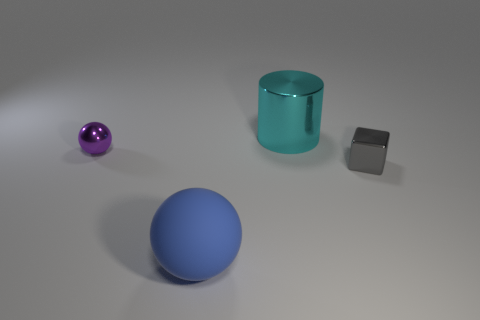Are there any purple metal spheres in front of the small purple sphere?
Give a very brief answer. No. How big is the block?
Ensure brevity in your answer.  Small. There is another object that is the same shape as the tiny purple metal thing; what is its size?
Offer a terse response. Large. How many large shiny objects are to the left of the tiny thing that is to the left of the big blue matte sphere?
Provide a succinct answer. 0. Is the thing in front of the small block made of the same material as the small thing that is on the right side of the cyan shiny thing?
Make the answer very short. No. What number of cyan metal objects are the same shape as the big matte object?
Ensure brevity in your answer.  0. There is a large object that is right of the big matte object; is it the same shape as the tiny object to the right of the blue sphere?
Your answer should be compact. No. There is a tiny object that is behind the shiny cube on the right side of the blue matte object; what number of tiny gray objects are behind it?
Provide a short and direct response. 0. What is the material of the small thing that is behind the tiny object in front of the tiny object that is on the left side of the gray metal cube?
Provide a short and direct response. Metal. Are the tiny object that is on the left side of the tiny gray metallic cube and the block made of the same material?
Provide a short and direct response. Yes. 